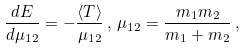<formula> <loc_0><loc_0><loc_500><loc_500>\frac { d E } { d \mu _ { 1 2 } } = - \frac { \langle T \rangle } { \mu _ { 1 2 } } \, , \, \mu _ { 1 2 } = \frac { m _ { 1 } m _ { 2 } } { m _ { 1 } + m _ { 2 } } \, ,</formula> 